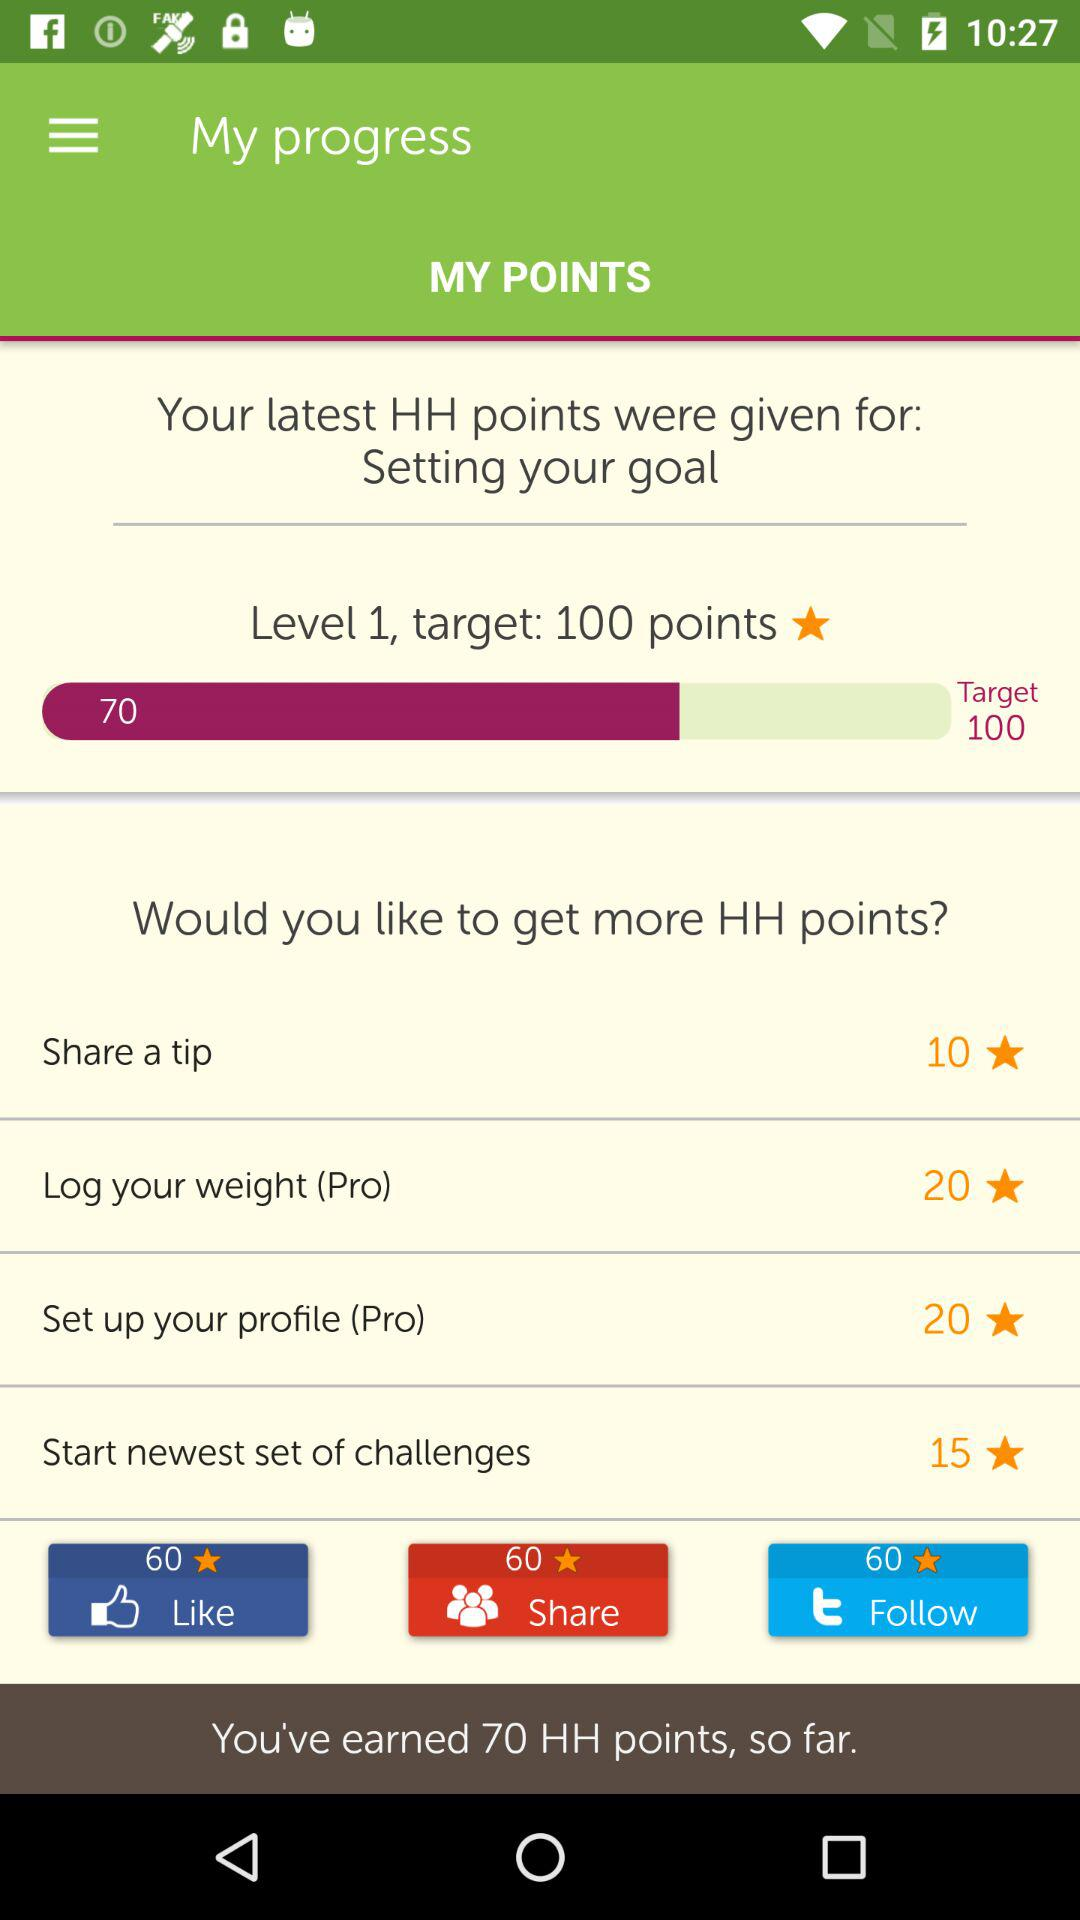How many points will be earned by starting the newest set of challenges? The number of points that will be earned by starting the newest set of challenges is 15. 